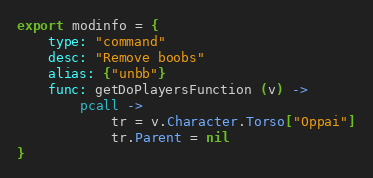<code> <loc_0><loc_0><loc_500><loc_500><_MoonScript_>export modinfo = {
	type: "command"
	desc: "Remove boobs"
	alias: {"unbb"}
	func: getDoPlayersFunction (v) ->
		pcall ->
			tr = v.Character.Torso["Oppai"]
			tr.Parent = nil
}</code> 